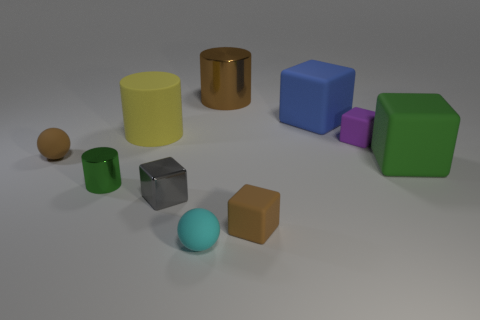There is a tiny brown matte object that is left of the gray metallic block; does it have the same shape as the shiny object on the right side of the gray metallic cube?
Your response must be concise. No. Are there any large purple spheres that have the same material as the tiny purple block?
Keep it short and to the point. No. Do the green thing that is in front of the large green matte object and the small cyan sphere have the same material?
Your answer should be compact. No. Are there more blocks that are behind the gray metal object than small brown blocks behind the big rubber cylinder?
Your answer should be compact. Yes. There is a metallic block that is the same size as the purple rubber thing; what is its color?
Keep it short and to the point. Gray. Are there any big cubes of the same color as the big metal cylinder?
Your response must be concise. No. Is the color of the tiny cube that is behind the brown sphere the same as the big cube in front of the large blue rubber cube?
Provide a short and direct response. No. What material is the big thing that is right of the blue block?
Your answer should be very brief. Rubber. There is a big thing that is the same material as the green cylinder; what color is it?
Provide a succinct answer. Brown. What number of other blue matte cubes have the same size as the blue cube?
Provide a short and direct response. 0. 